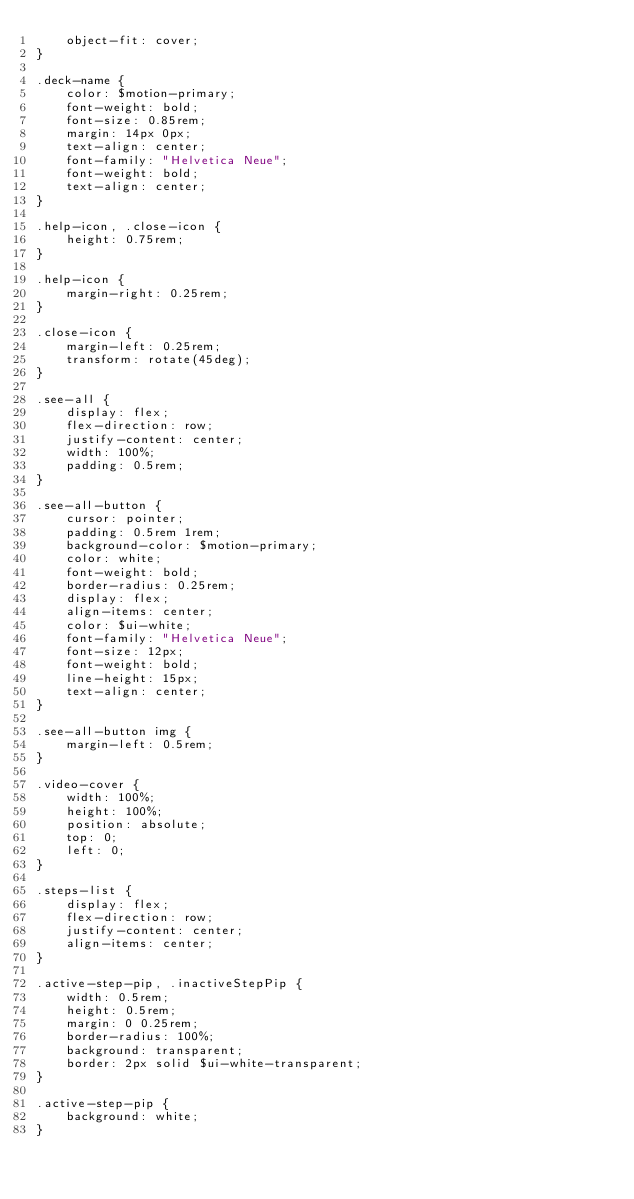Convert code to text. <code><loc_0><loc_0><loc_500><loc_500><_CSS_>    object-fit: cover;
}

.deck-name {
    color: $motion-primary;
    font-weight: bold;
    font-size: 0.85rem;
    margin: 14px 0px;
    text-align: center;
    font-family: "Helvetica Neue";
    font-weight: bold;
    text-align: center;
}

.help-icon, .close-icon {
    height: 0.75rem;
}

.help-icon {
    margin-right: 0.25rem;
}

.close-icon {
    margin-left: 0.25rem;
    transform: rotate(45deg);
}

.see-all {
    display: flex;
    flex-direction: row;
    justify-content: center;
    width: 100%;
    padding: 0.5rem;
}

.see-all-button {
    cursor: pointer;
    padding: 0.5rem 1rem;
    background-color: $motion-primary;
    color: white;
    font-weight: bold;
    border-radius: 0.25rem;
    display: flex;
    align-items: center;
    color: $ui-white;
    font-family: "Helvetica Neue";
    font-size: 12px;
    font-weight: bold;
    line-height: 15px;
    text-align: center;
}

.see-all-button img {
    margin-left: 0.5rem;
}

.video-cover {
    width: 100%;
    height: 100%;
    position: absolute;
    top: 0;
    left: 0;
}

.steps-list {
    display: flex;
    flex-direction: row;
    justify-content: center;
    align-items: center;
}

.active-step-pip, .inactiveStepPip {
    width: 0.5rem;
    height: 0.5rem;
    margin: 0 0.25rem;
    border-radius: 100%;
    background: transparent;
    border: 2px solid $ui-white-transparent;
}

.active-step-pip {
    background: white;
}
</code> 